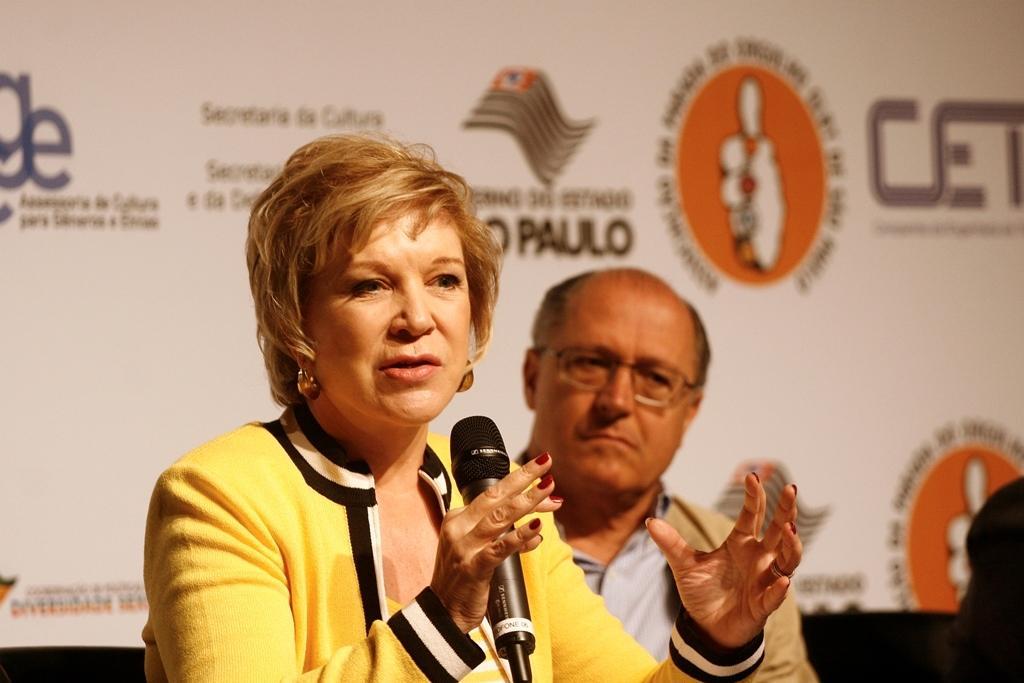Can you describe this image briefly? In the middle of the image a woman is holding the microphone and speaking. Behind the woman there a man. He is watching. Behind the man there is a screen. 